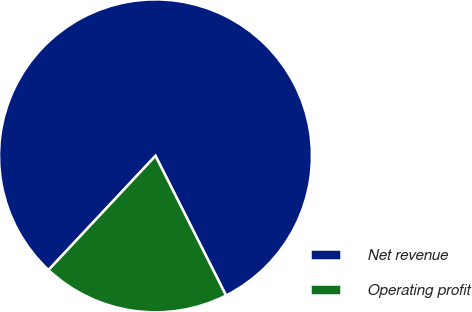Convert chart to OTSL. <chart><loc_0><loc_0><loc_500><loc_500><pie_chart><fcel>Net revenue<fcel>Operating profit<nl><fcel>80.57%<fcel>19.43%<nl></chart> 